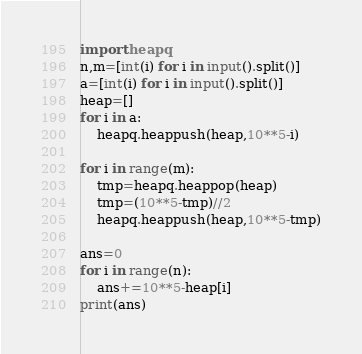<code> <loc_0><loc_0><loc_500><loc_500><_Python_>import heapq
n,m=[int(i) for i in input().split()]
a=[int(i) for i in input().split()]
heap=[]
for i in a:
    heapq.heappush(heap,10**5-i)

for i in range(m):
    tmp=heapq.heappop(heap)
    tmp=(10**5-tmp)//2
    heapq.heappush(heap,10**5-tmp)

ans=0
for i in range(n):
    ans+=10**5-heap[i]
print(ans)</code> 